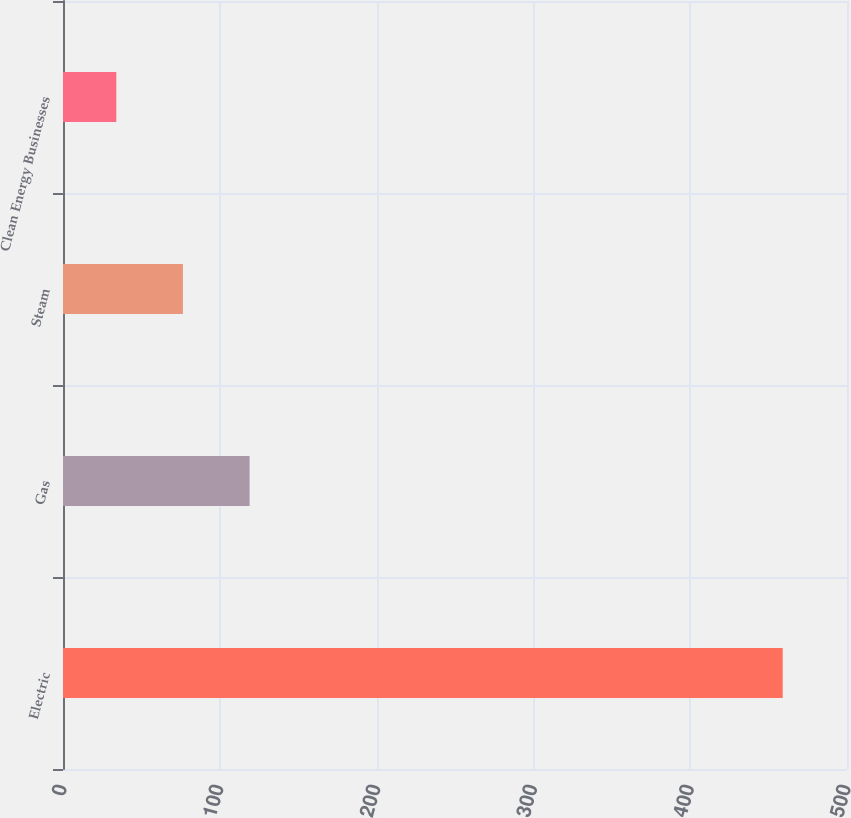<chart> <loc_0><loc_0><loc_500><loc_500><bar_chart><fcel>Electric<fcel>Gas<fcel>Steam<fcel>Clean Energy Businesses<nl><fcel>459<fcel>119<fcel>76.5<fcel>34<nl></chart> 